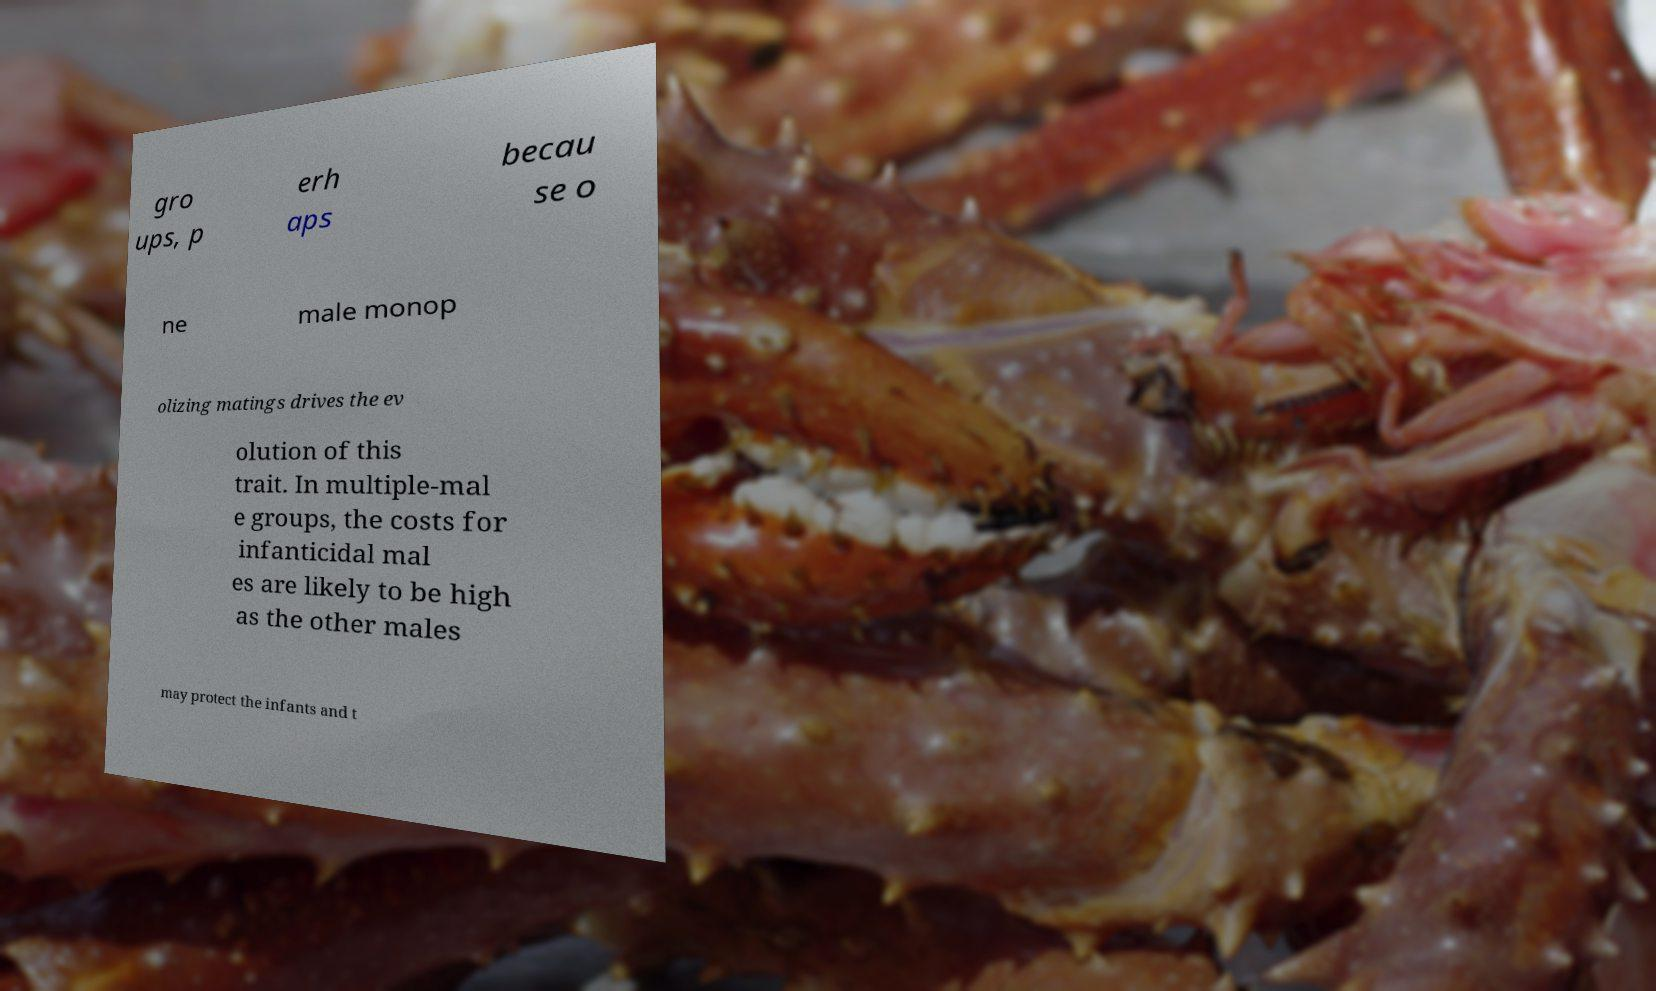Could you extract and type out the text from this image? gro ups, p erh aps becau se o ne male monop olizing matings drives the ev olution of this trait. In multiple-mal e groups, the costs for infanticidal mal es are likely to be high as the other males may protect the infants and t 